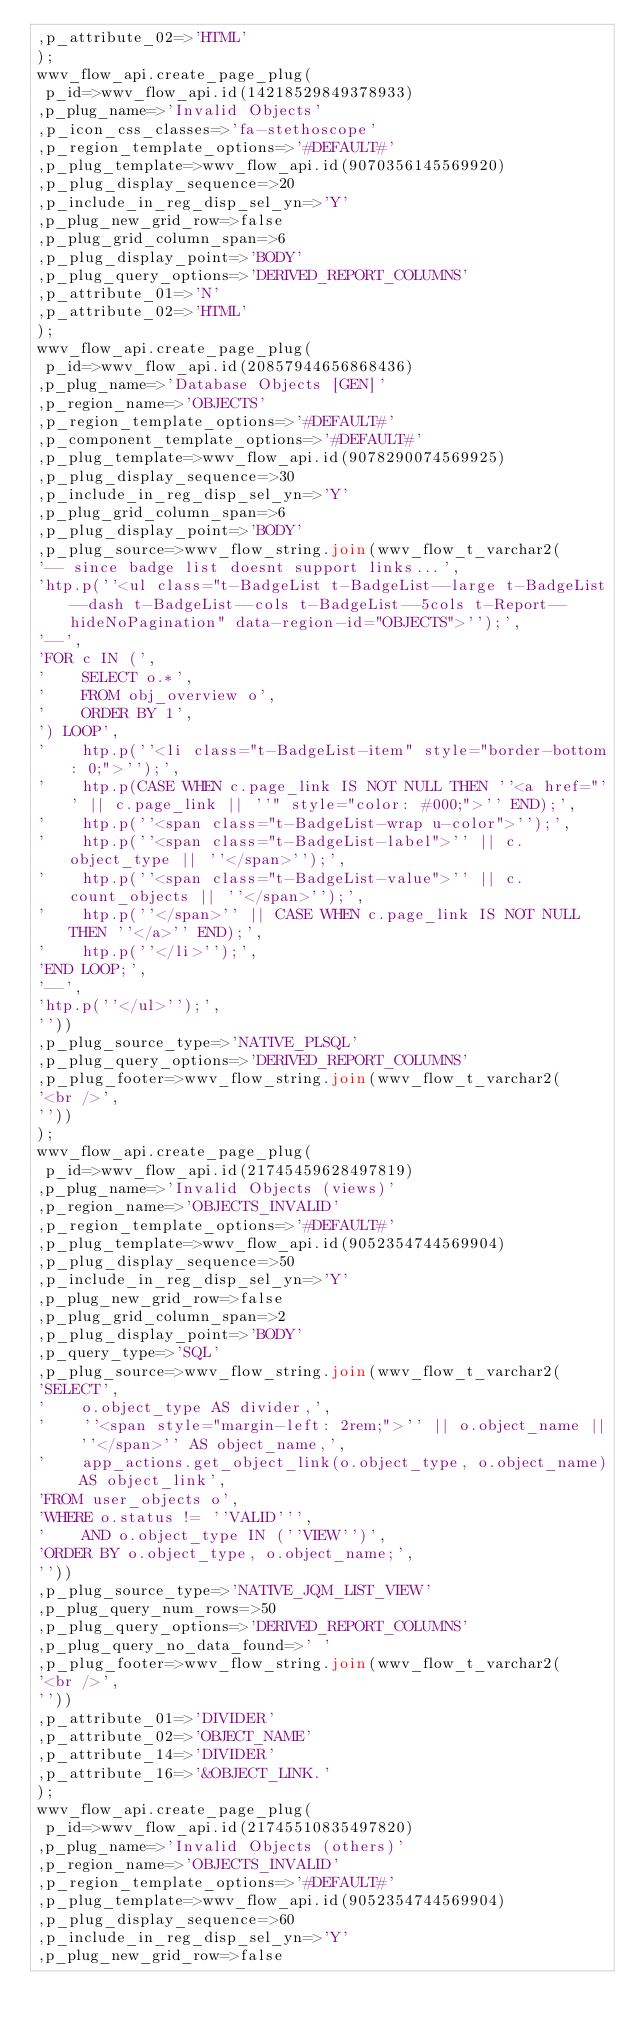Convert code to text. <code><loc_0><loc_0><loc_500><loc_500><_SQL_>,p_attribute_02=>'HTML'
);
wwv_flow_api.create_page_plug(
 p_id=>wwv_flow_api.id(14218529849378933)
,p_plug_name=>'Invalid Objects'
,p_icon_css_classes=>'fa-stethoscope'
,p_region_template_options=>'#DEFAULT#'
,p_plug_template=>wwv_flow_api.id(9070356145569920)
,p_plug_display_sequence=>20
,p_include_in_reg_disp_sel_yn=>'Y'
,p_plug_new_grid_row=>false
,p_plug_grid_column_span=>6
,p_plug_display_point=>'BODY'
,p_plug_query_options=>'DERIVED_REPORT_COLUMNS'
,p_attribute_01=>'N'
,p_attribute_02=>'HTML'
);
wwv_flow_api.create_page_plug(
 p_id=>wwv_flow_api.id(20857944656868436)
,p_plug_name=>'Database Objects [GEN]'
,p_region_name=>'OBJECTS'
,p_region_template_options=>'#DEFAULT#'
,p_component_template_options=>'#DEFAULT#'
,p_plug_template=>wwv_flow_api.id(9078290074569925)
,p_plug_display_sequence=>30
,p_include_in_reg_disp_sel_yn=>'Y'
,p_plug_grid_column_span=>6
,p_plug_display_point=>'BODY'
,p_plug_source=>wwv_flow_string.join(wwv_flow_t_varchar2(
'-- since badge list doesnt support links...',
'htp.p(''<ul class="t-BadgeList t-BadgeList--large t-BadgeList--dash t-BadgeList--cols t-BadgeList--5cols t-Report--hideNoPagination" data-region-id="OBJECTS">'');',
'--',
'FOR c IN (',
'    SELECT o.*',
'    FROM obj_overview o',
'    ORDER BY 1',
') LOOP',
'    htp.p(''<li class="t-BadgeList-item" style="border-bottom: 0;">'');',
'    htp.p(CASE WHEN c.page_link IS NOT NULL THEN ''<a href="'' || c.page_link || ''" style="color: #000;">'' END);',
'    htp.p(''<span class="t-BadgeList-wrap u-color">'');',
'    htp.p(''<span class="t-BadgeList-label">'' || c.object_type || ''</span>'');',
'    htp.p(''<span class="t-BadgeList-value">'' || c.count_objects || ''</span>'');',
'    htp.p(''</span>'' || CASE WHEN c.page_link IS NOT NULL THEN ''</a>'' END);',
'    htp.p(''</li>'');',
'END LOOP;',
'--',
'htp.p(''</ul>'');',
''))
,p_plug_source_type=>'NATIVE_PLSQL'
,p_plug_query_options=>'DERIVED_REPORT_COLUMNS'
,p_plug_footer=>wwv_flow_string.join(wwv_flow_t_varchar2(
'<br />',
''))
);
wwv_flow_api.create_page_plug(
 p_id=>wwv_flow_api.id(21745459628497819)
,p_plug_name=>'Invalid Objects (views)'
,p_region_name=>'OBJECTS_INVALID'
,p_region_template_options=>'#DEFAULT#'
,p_plug_template=>wwv_flow_api.id(9052354744569904)
,p_plug_display_sequence=>50
,p_include_in_reg_disp_sel_yn=>'Y'
,p_plug_new_grid_row=>false
,p_plug_grid_column_span=>2
,p_plug_display_point=>'BODY'
,p_query_type=>'SQL'
,p_plug_source=>wwv_flow_string.join(wwv_flow_t_varchar2(
'SELECT',
'    o.object_type AS divider,',
'    ''<span style="margin-left: 2rem;">'' || o.object_name || ''</span>'' AS object_name,',
'    app_actions.get_object_link(o.object_type, o.object_name) AS object_link',
'FROM user_objects o',
'WHERE o.status != ''VALID''',
'    AND o.object_type IN (''VIEW'')',
'ORDER BY o.object_type, o.object_name;',
''))
,p_plug_source_type=>'NATIVE_JQM_LIST_VIEW'
,p_plug_query_num_rows=>50
,p_plug_query_options=>'DERIVED_REPORT_COLUMNS'
,p_plug_query_no_data_found=>' '
,p_plug_footer=>wwv_flow_string.join(wwv_flow_t_varchar2(
'<br />',
''))
,p_attribute_01=>'DIVIDER'
,p_attribute_02=>'OBJECT_NAME'
,p_attribute_14=>'DIVIDER'
,p_attribute_16=>'&OBJECT_LINK.'
);
wwv_flow_api.create_page_plug(
 p_id=>wwv_flow_api.id(21745510835497820)
,p_plug_name=>'Invalid Objects (others)'
,p_region_name=>'OBJECTS_INVALID'
,p_region_template_options=>'#DEFAULT#'
,p_plug_template=>wwv_flow_api.id(9052354744569904)
,p_plug_display_sequence=>60
,p_include_in_reg_disp_sel_yn=>'Y'
,p_plug_new_grid_row=>false</code> 